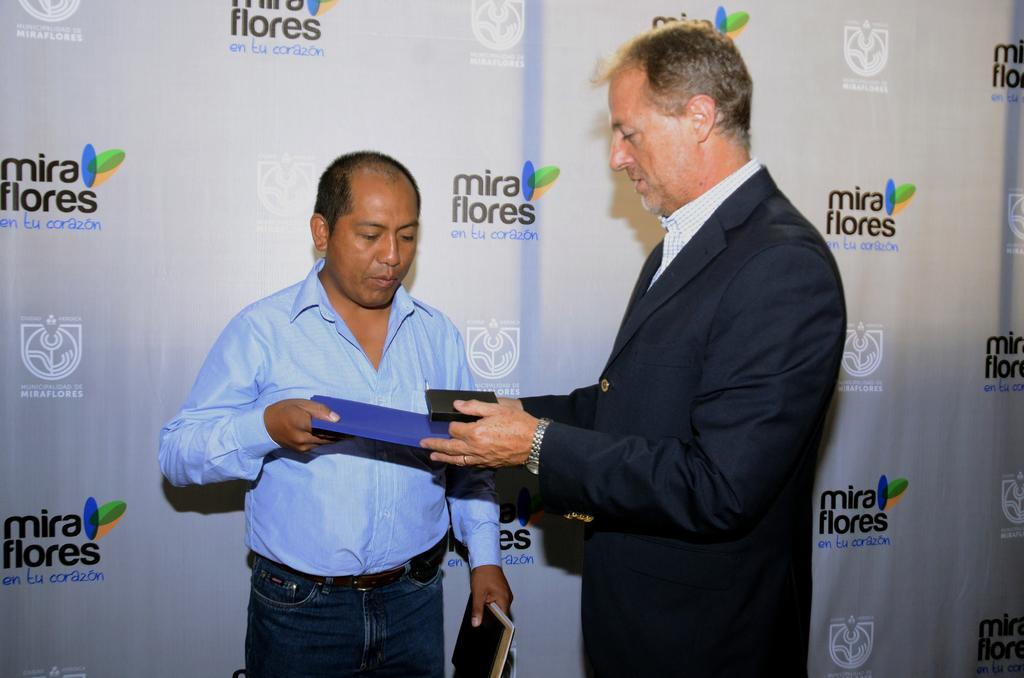How many people are in the image? There are two men in the image. Where are the men located in the image? The men are in the center of the image. What are the men holding in the image? The men are holding a book. What can be seen in the background of the image? There is a flex in the background of the image. What type of scent can be detected from the book in the image? There is no indication of a scent in the image, as it only shows two men holding a book and a flex in the background. 